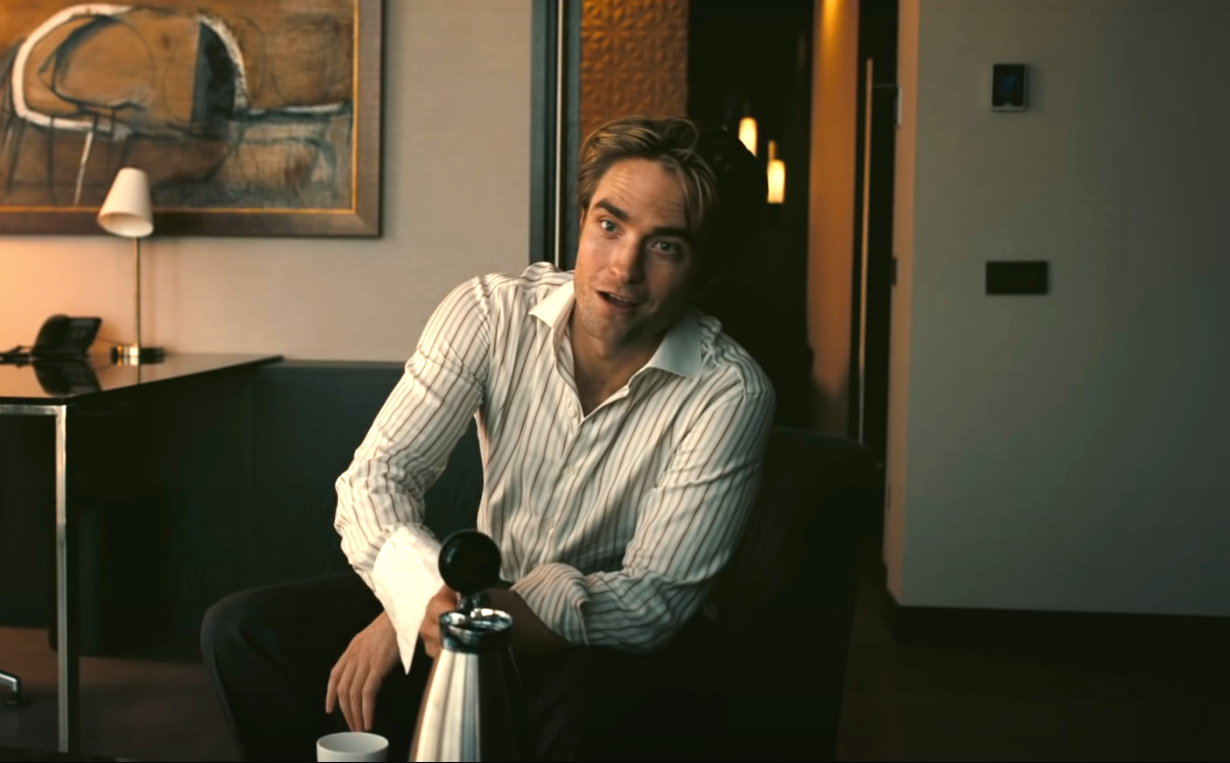Write a detailed description of the given image. In the image, a well-dressed man is seated on a sleek, black leather couch in a sophisticated living room. He wears a white, striped shirt and holds a silver water pitcher. His relaxed posture, along with a faint smile on his lips, suggests he is in a pleasant and peaceful mood. His gaze is directed to the side, giving an impression of contemplation or perhaps a pleasant interaction outside the frame. The room is tastefully decorated with a painting on the wall behind him, a small lamp on a table, and a modern decor, contributing to an overall atmosphere of elegance and tranquility. 